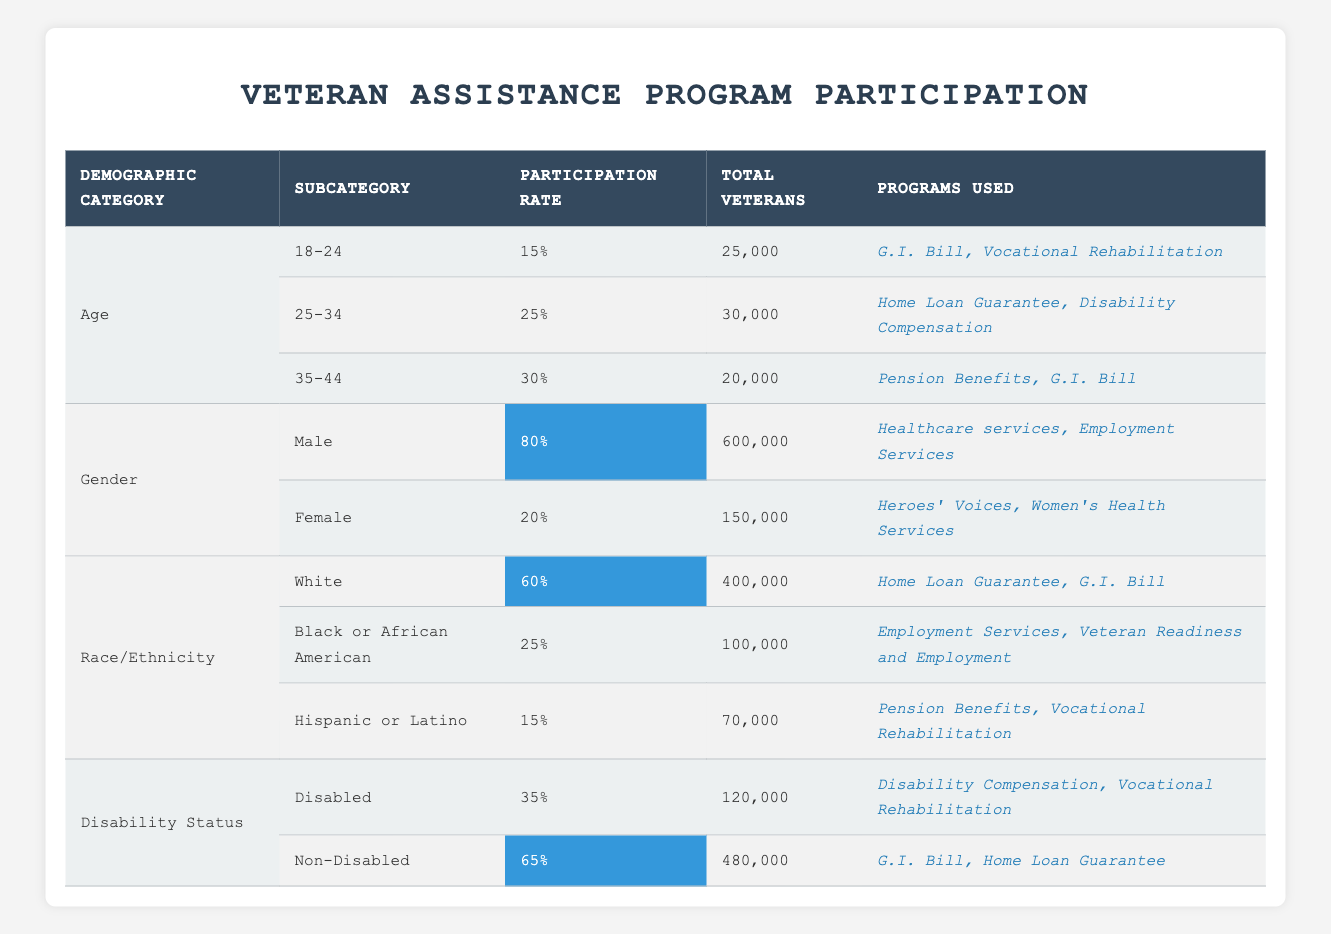What is the participation rate for veterans aged 25-34? The table shows that the age group 25-34 has a participation rate highlighted as 25%.
Answer: 25% How many total veterans are participating in the G.I. Bill program? The G.I. Bill is mentioned in the participation rates for age groups 18-24 and 35-44, which totals 25000 + 20000 = 45000 veterans.
Answer: 45000 What percentage of disabled veterans participate in veteran assistance programs? The table lists the participation rate for disabled veterans as 35%.
Answer: 35% Which demographic category has the highest participation rate? The gender category shows that male veterans have a participation rate of 80%, which is the highest in the table.
Answer: Male veterans at 80% What is the total number of non-disabled veterans utilizing assistance programs? The table states there are 480,000 non-disabled veterans participating in these programs.
Answer: 480000 Is the participation rate for female veterans higher than that of Hispanic or Latino veterans? The participation rate for female veterans is 20%, while for Hispanic or Latino veterans, it is only 15%. Therefore, the statement is true.
Answer: Yes How much more likely are non-disabled veterans to participate compared to disabled veterans? Non-disabled veterans have a participation rate of 65%, while disabled veterans have 35%. The difference is 65 - 35 = 30%.
Answer: 30% What is the total number of veterans from all age groups participating in programs? The total number of veterans across all age groups is 25000 + 30000 + 20000 = 75000.
Answer: 75000 Are there more programs utilized by male veterans or female veterans? Male veterans have access to 2 programs (Healthcare services and Employment Services), whereas female veterans also utilize 2 programs (Heroes' Voices and Women's Health Services). Thus, they have the same number of programs.
Answer: Same number of programs What is the average participation rate among all racial/ethnic groups listed in the table? The participation rates for the racial/ethnic groups are 60%, 25%, and 15%. The average is calculated as (60 + 25 + 15) / 3 = 100 / 3 ≈ 33.33%.
Answer: Approximately 33.33% 